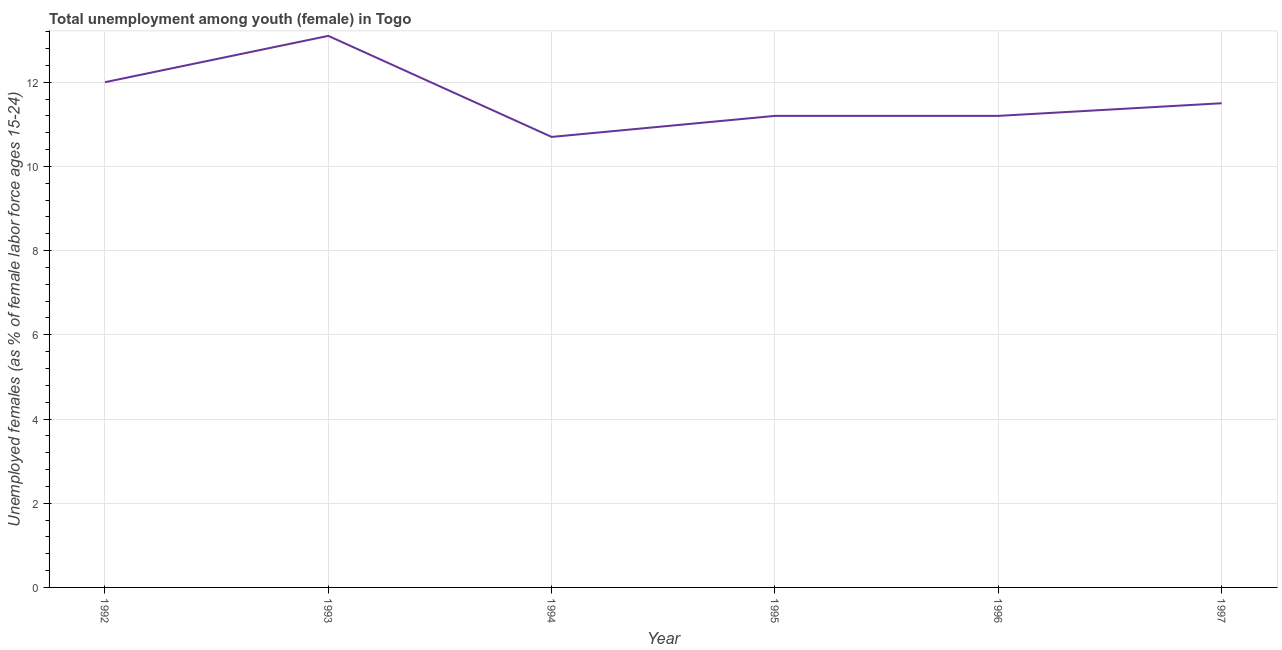What is the unemployed female youth population in 1993?
Ensure brevity in your answer.  13.1. Across all years, what is the maximum unemployed female youth population?
Provide a succinct answer. 13.1. Across all years, what is the minimum unemployed female youth population?
Your answer should be compact. 10.7. What is the sum of the unemployed female youth population?
Provide a succinct answer. 69.7. What is the difference between the unemployed female youth population in 1992 and 1997?
Give a very brief answer. 0.5. What is the average unemployed female youth population per year?
Keep it short and to the point. 11.62. What is the median unemployed female youth population?
Ensure brevity in your answer.  11.35. In how many years, is the unemployed female youth population greater than 0.8 %?
Provide a succinct answer. 6. What is the ratio of the unemployed female youth population in 1993 to that in 1996?
Your answer should be very brief. 1.17. What is the difference between the highest and the second highest unemployed female youth population?
Provide a short and direct response. 1.1. What is the difference between the highest and the lowest unemployed female youth population?
Make the answer very short. 2.4. Are the values on the major ticks of Y-axis written in scientific E-notation?
Give a very brief answer. No. What is the title of the graph?
Your answer should be compact. Total unemployment among youth (female) in Togo. What is the label or title of the Y-axis?
Keep it short and to the point. Unemployed females (as % of female labor force ages 15-24). What is the Unemployed females (as % of female labor force ages 15-24) of 1992?
Keep it short and to the point. 12. What is the Unemployed females (as % of female labor force ages 15-24) of 1993?
Offer a very short reply. 13.1. What is the Unemployed females (as % of female labor force ages 15-24) in 1994?
Your answer should be compact. 10.7. What is the Unemployed females (as % of female labor force ages 15-24) in 1995?
Ensure brevity in your answer.  11.2. What is the Unemployed females (as % of female labor force ages 15-24) of 1996?
Ensure brevity in your answer.  11.2. What is the difference between the Unemployed females (as % of female labor force ages 15-24) in 1992 and 1994?
Your answer should be very brief. 1.3. What is the difference between the Unemployed females (as % of female labor force ages 15-24) in 1992 and 1995?
Offer a very short reply. 0.8. What is the difference between the Unemployed females (as % of female labor force ages 15-24) in 1992 and 1996?
Your answer should be compact. 0.8. What is the difference between the Unemployed females (as % of female labor force ages 15-24) in 1992 and 1997?
Your response must be concise. 0.5. What is the difference between the Unemployed females (as % of female labor force ages 15-24) in 1993 and 1994?
Your answer should be very brief. 2.4. What is the difference between the Unemployed females (as % of female labor force ages 15-24) in 1993 and 1996?
Your answer should be very brief. 1.9. What is the difference between the Unemployed females (as % of female labor force ages 15-24) in 1993 and 1997?
Your response must be concise. 1.6. What is the difference between the Unemployed females (as % of female labor force ages 15-24) in 1994 and 1997?
Offer a very short reply. -0.8. What is the difference between the Unemployed females (as % of female labor force ages 15-24) in 1996 and 1997?
Provide a short and direct response. -0.3. What is the ratio of the Unemployed females (as % of female labor force ages 15-24) in 1992 to that in 1993?
Your answer should be very brief. 0.92. What is the ratio of the Unemployed females (as % of female labor force ages 15-24) in 1992 to that in 1994?
Your answer should be compact. 1.12. What is the ratio of the Unemployed females (as % of female labor force ages 15-24) in 1992 to that in 1995?
Provide a short and direct response. 1.07. What is the ratio of the Unemployed females (as % of female labor force ages 15-24) in 1992 to that in 1996?
Your answer should be very brief. 1.07. What is the ratio of the Unemployed females (as % of female labor force ages 15-24) in 1992 to that in 1997?
Your response must be concise. 1.04. What is the ratio of the Unemployed females (as % of female labor force ages 15-24) in 1993 to that in 1994?
Give a very brief answer. 1.22. What is the ratio of the Unemployed females (as % of female labor force ages 15-24) in 1993 to that in 1995?
Your response must be concise. 1.17. What is the ratio of the Unemployed females (as % of female labor force ages 15-24) in 1993 to that in 1996?
Provide a short and direct response. 1.17. What is the ratio of the Unemployed females (as % of female labor force ages 15-24) in 1993 to that in 1997?
Your answer should be very brief. 1.14. What is the ratio of the Unemployed females (as % of female labor force ages 15-24) in 1994 to that in 1995?
Offer a very short reply. 0.95. What is the ratio of the Unemployed females (as % of female labor force ages 15-24) in 1994 to that in 1996?
Provide a succinct answer. 0.95. 